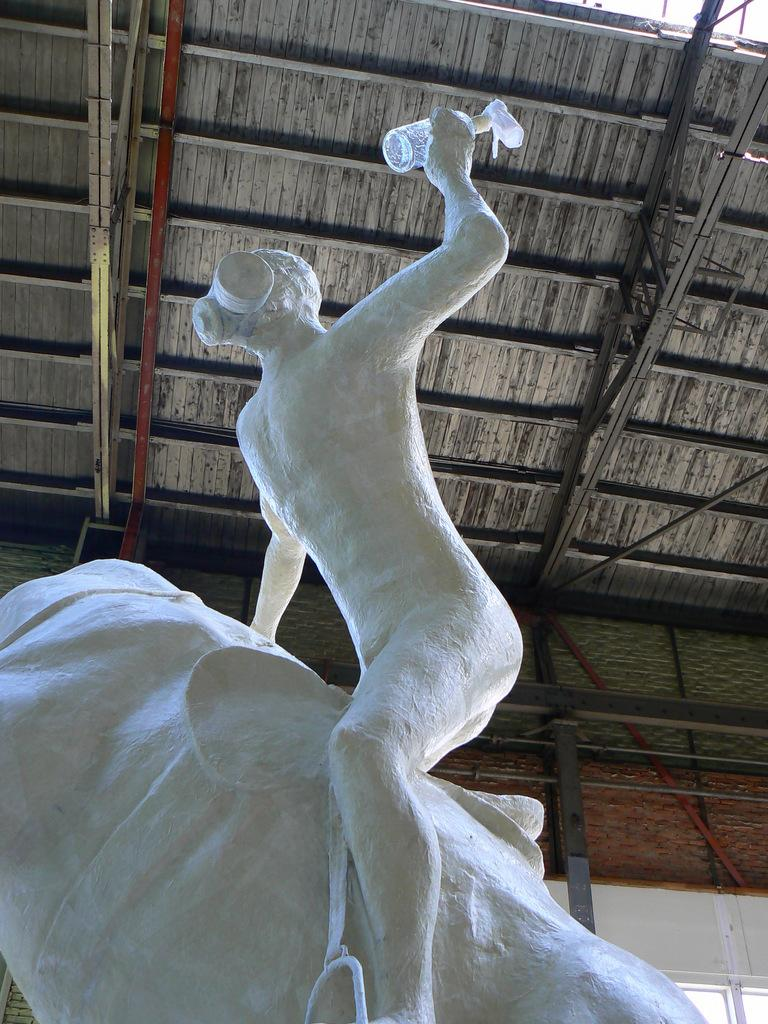What is the main subject in the center of the image? There is a statue in the center of the image. What can be seen in the background of the image? There is a shed in the background of the image. What type of dog is playing with a paintbrush in the image? There is no dog or paintbrush present in the image. 